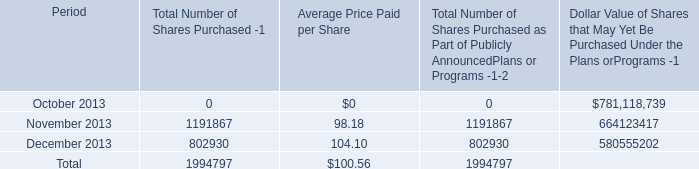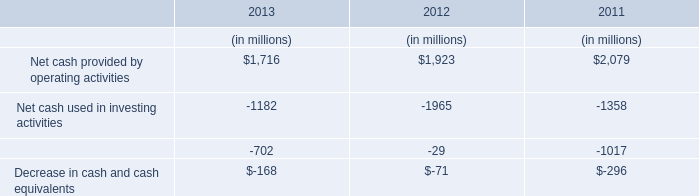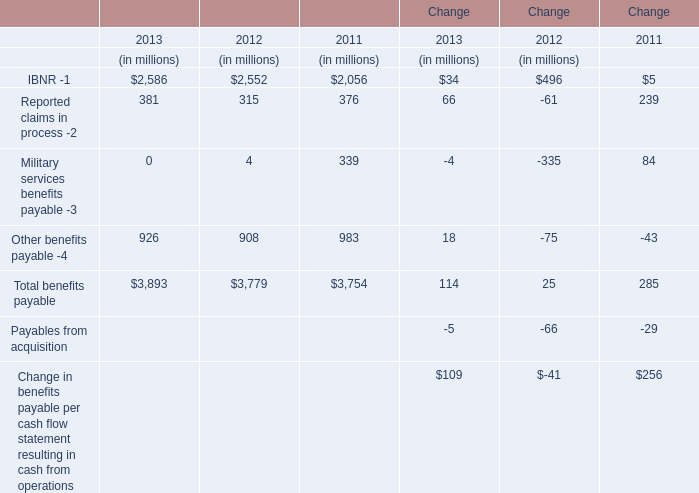What is the sum of the Reported claims in process -2 in the years where IBNR -1 greater than 2500? (in million) 
Computations: (381 + 315)
Answer: 696.0. 